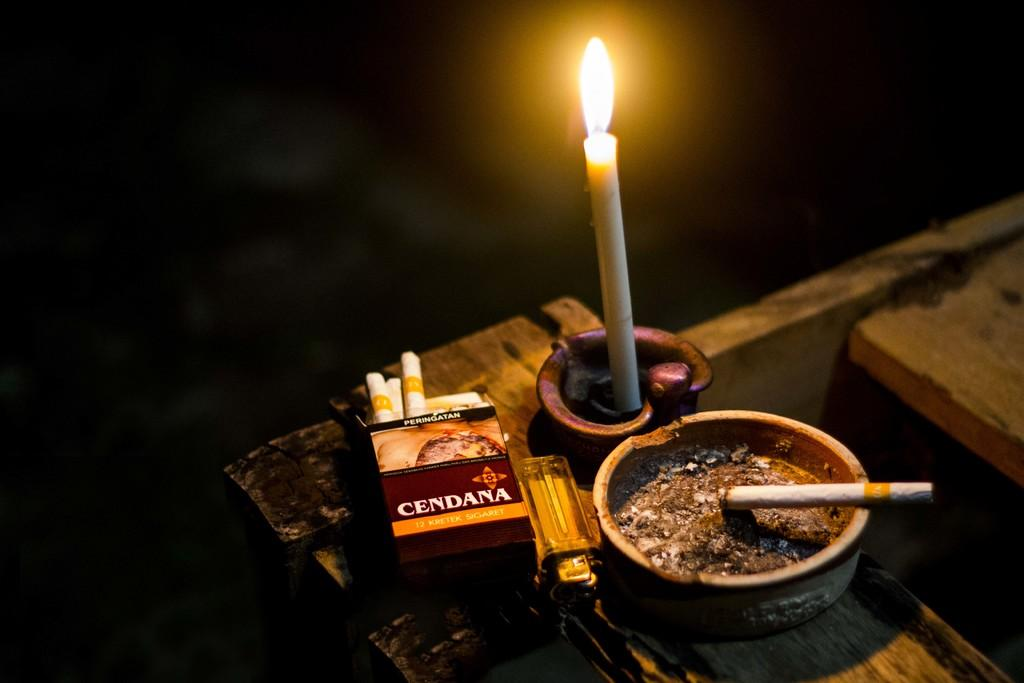What is the main object in the image? There is a candle in the image. What other items can be seen in the image? There are cigarettes, a box, a lighter, and a container in the image. What might be used to ignite the candle or cigarettes? The lighter in the image can be used to ignite the candle or cigarettes. What type of grass can be seen growing around the candle in the image? There is no grass present in the image; it features a candle, cigarettes, a box, a lighter, and a container. 